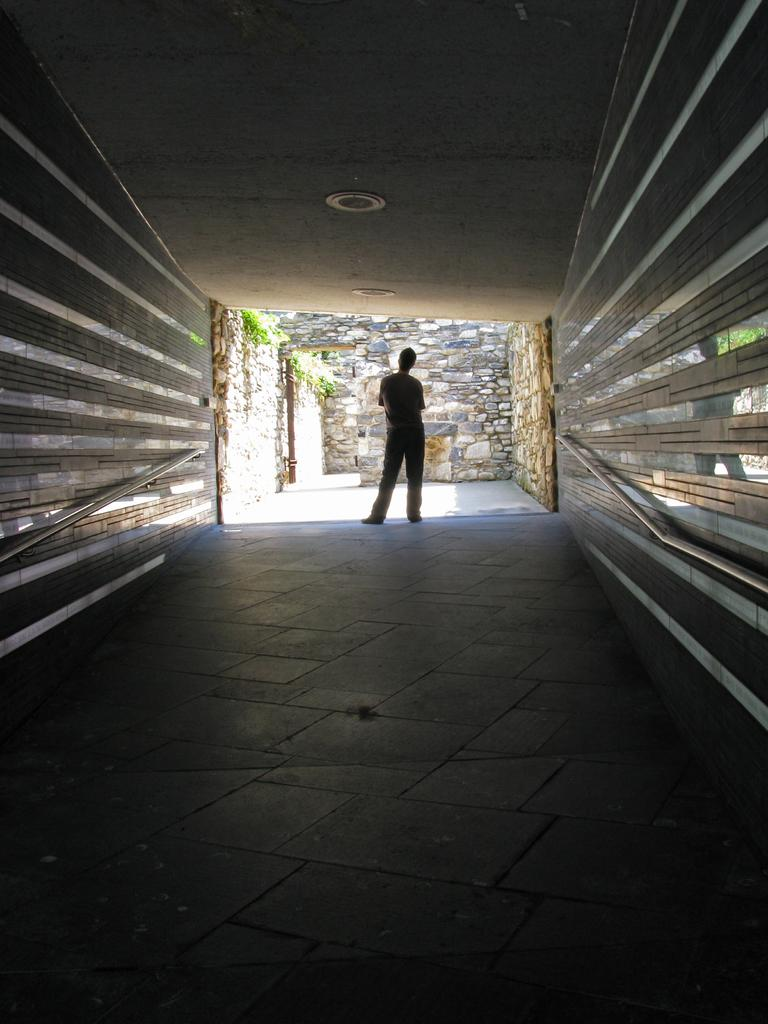What is the main subject of the image? There is a person standing in the image. Where is the person standing? The person is standing on the floor. What can be seen above the person in the image? There is a ceiling with lights in the image. What surrounds the person in the image? There are walls visible in the image. What type of scarecrow can be seen in the hospital in the image? There is no scarecrow or hospital present in the image; it features a person standing in a room with walls, a ceiling, and lights. How many balls are visible in the image? There are no balls visible in the image. 